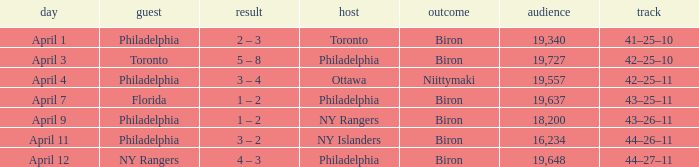What was the flyers' record when the visitors were florida? 43–25–11. 